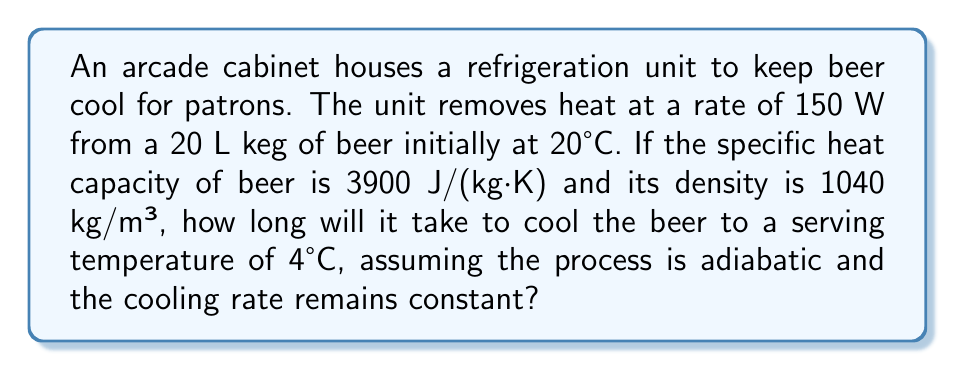Can you solve this math problem? To solve this problem, we'll follow these steps:

1. Calculate the mass of beer:
   Volume = 20 L = 0.02 m³
   Density = 1040 kg/m³
   Mass = Density × Volume
   $m = 1040 \text{ kg/m³} \times 0.02 \text{ m³} = 20.8 \text{ kg}$

2. Calculate the energy that needs to be removed:
   $Q = mc\Delta T$
   Where:
   $m$ = mass of beer (20.8 kg)
   $c$ = specific heat capacity (3900 J/(kg·K))
   $\Delta T$ = temperature change (20°C - 4°C = 16 K)

   $Q = 20.8 \text{ kg} \times 3900 \text{ J/(kg·K)} \times 16 \text{ K}$
   $Q = 1,299,200 \text{ J}$

3. Calculate the time required:
   Power = Energy / Time
   $P = \frac{Q}{t}$

   Rearranging for time:
   $t = \frac{Q}{P}$

   $t = \frac{1,299,200 \text{ J}}{150 \text{ W}}$
   $t = 8,661.33 \text{ seconds}$

4. Convert seconds to hours:
   $t = \frac{8,661.33 \text{ seconds}}{3600 \text{ seconds/hour}} = 2.41 \text{ hours}$

Therefore, it will take approximately 2.41 hours to cool the beer from 20°C to 4°C under the given conditions.
Answer: 2.41 hours 